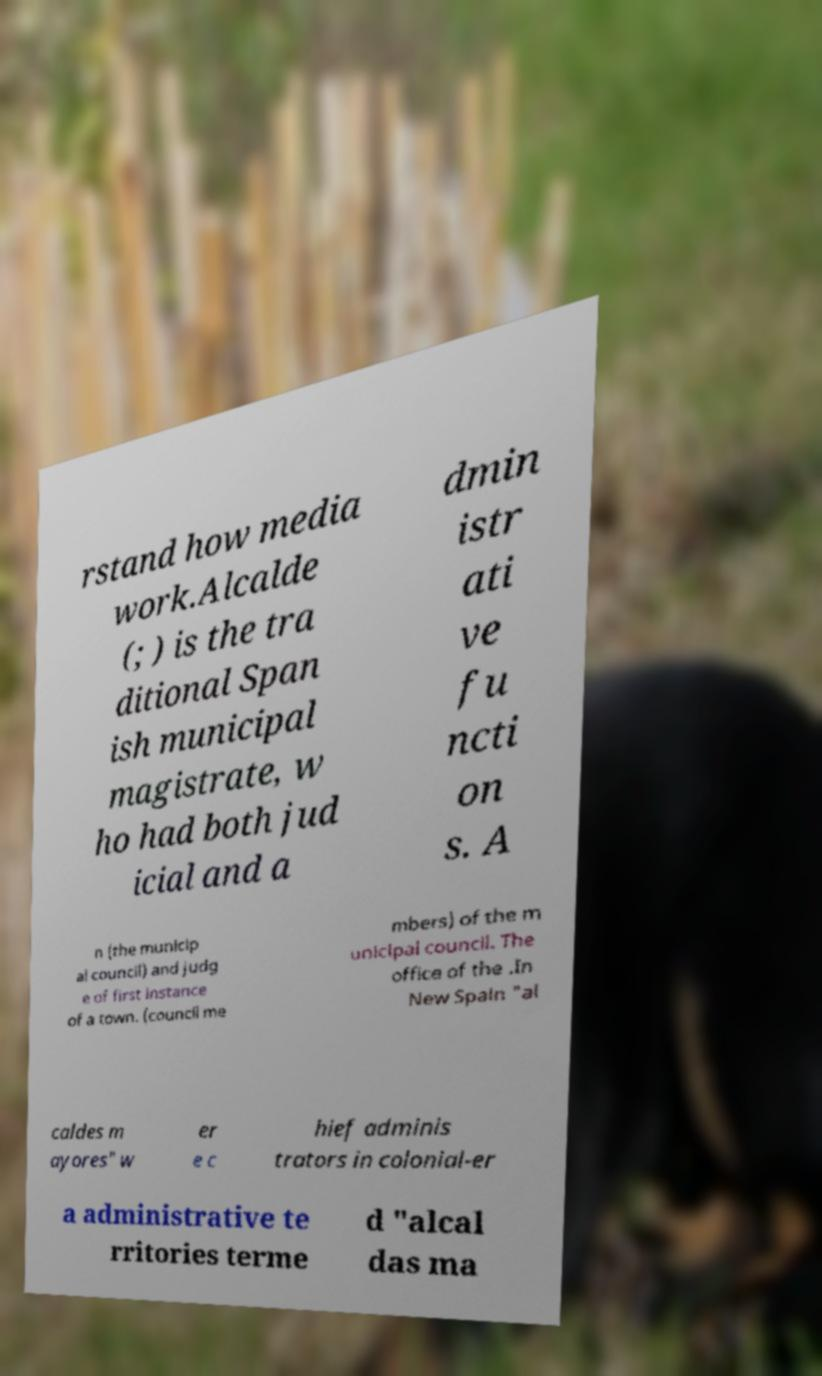What messages or text are displayed in this image? I need them in a readable, typed format. rstand how media work.Alcalde (; ) is the tra ditional Span ish municipal magistrate, w ho had both jud icial and a dmin istr ati ve fu ncti on s. A n (the municip al council) and judg e of first instance of a town. (council me mbers) of the m unicipal council. The office of the .In New Spain "al caldes m ayores" w er e c hief adminis trators in colonial-er a administrative te rritories terme d "alcal das ma 